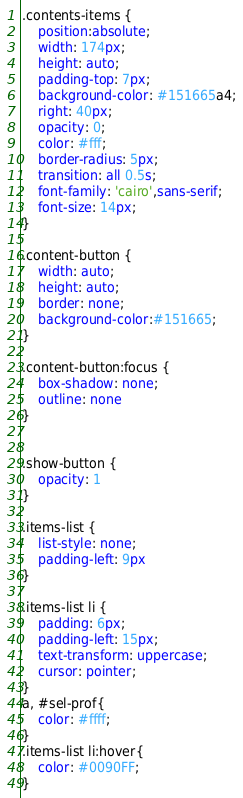Convert code to text. <code><loc_0><loc_0><loc_500><loc_500><_CSS_>.contents-items {
    position:absolute;
    width: 174px;
    height: auto;
    padding-top: 7px;
    background-color: #151665a4;
    right: 40px;
    opacity: 0;
    color: #fff;
    border-radius: 5px;
    transition: all 0.5s;
    font-family: 'cairo',sans-serif;
    font-size: 14px;
}

.content-button {
    width: auto;
    height: auto;
    border: none;
    background-color:#151665;
}

.content-button:focus {
    box-shadow: none;
    outline: none
}


.show-button {
    opacity: 1
}

.items-list {
    list-style: none;
    padding-left: 9px
}

.items-list li {
    padding: 6px;
    padding-left: 15px;
    text-transform: uppercase;
    cursor: pointer;
}
a, #sel-prof{
    color: #ffff;
}
.items-list li:hover{
    color: #0090FF;
}
</code> 